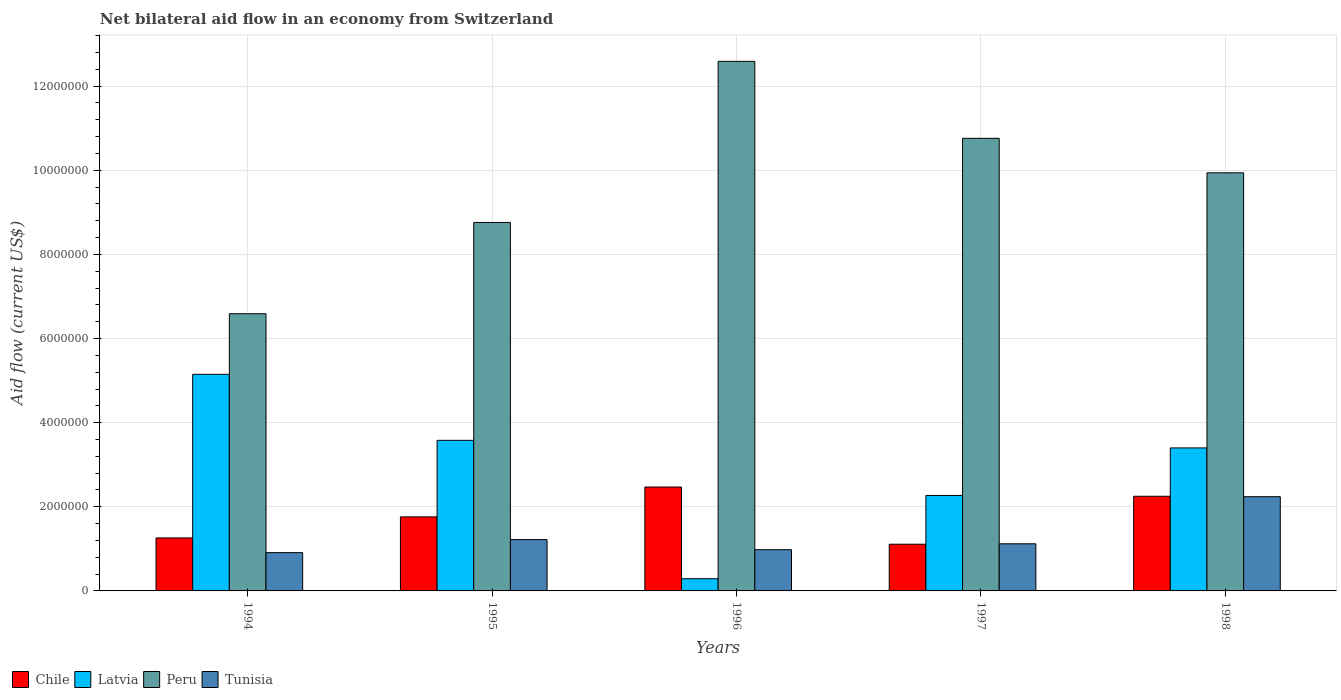How many different coloured bars are there?
Keep it short and to the point. 4. Are the number of bars per tick equal to the number of legend labels?
Your response must be concise. Yes. How many bars are there on the 1st tick from the left?
Your response must be concise. 4. What is the label of the 4th group of bars from the left?
Offer a terse response. 1997. What is the net bilateral aid flow in Peru in 1994?
Provide a short and direct response. 6.59e+06. Across all years, what is the maximum net bilateral aid flow in Chile?
Ensure brevity in your answer.  2.47e+06. Across all years, what is the minimum net bilateral aid flow in Latvia?
Your answer should be compact. 2.90e+05. In which year was the net bilateral aid flow in Chile maximum?
Offer a terse response. 1996. What is the total net bilateral aid flow in Peru in the graph?
Keep it short and to the point. 4.86e+07. What is the difference between the net bilateral aid flow in Chile in 1995 and that in 1996?
Provide a short and direct response. -7.10e+05. What is the difference between the net bilateral aid flow in Latvia in 1996 and the net bilateral aid flow in Tunisia in 1994?
Give a very brief answer. -6.20e+05. What is the average net bilateral aid flow in Peru per year?
Give a very brief answer. 9.73e+06. In the year 1994, what is the difference between the net bilateral aid flow in Latvia and net bilateral aid flow in Peru?
Offer a very short reply. -1.44e+06. In how many years, is the net bilateral aid flow in Latvia greater than 3600000 US$?
Offer a very short reply. 1. What is the ratio of the net bilateral aid flow in Tunisia in 1997 to that in 1998?
Your answer should be compact. 0.5. Is the net bilateral aid flow in Tunisia in 1995 less than that in 1997?
Your response must be concise. No. Is the difference between the net bilateral aid flow in Latvia in 1995 and 1998 greater than the difference between the net bilateral aid flow in Peru in 1995 and 1998?
Provide a short and direct response. Yes. What is the difference between the highest and the second highest net bilateral aid flow in Tunisia?
Provide a succinct answer. 1.02e+06. What is the difference between the highest and the lowest net bilateral aid flow in Chile?
Your response must be concise. 1.36e+06. Is the sum of the net bilateral aid flow in Latvia in 1995 and 1998 greater than the maximum net bilateral aid flow in Chile across all years?
Provide a succinct answer. Yes. Is it the case that in every year, the sum of the net bilateral aid flow in Chile and net bilateral aid flow in Peru is greater than the net bilateral aid flow in Latvia?
Keep it short and to the point. Yes. How many bars are there?
Provide a succinct answer. 20. Are all the bars in the graph horizontal?
Keep it short and to the point. No. How many years are there in the graph?
Your answer should be very brief. 5. What is the difference between two consecutive major ticks on the Y-axis?
Ensure brevity in your answer.  2.00e+06. Are the values on the major ticks of Y-axis written in scientific E-notation?
Offer a terse response. No. Does the graph contain any zero values?
Offer a very short reply. No. Does the graph contain grids?
Provide a short and direct response. Yes. Where does the legend appear in the graph?
Keep it short and to the point. Bottom left. What is the title of the graph?
Make the answer very short. Net bilateral aid flow in an economy from Switzerland. Does "Ukraine" appear as one of the legend labels in the graph?
Offer a very short reply. No. What is the label or title of the X-axis?
Provide a succinct answer. Years. What is the Aid flow (current US$) of Chile in 1994?
Provide a short and direct response. 1.26e+06. What is the Aid flow (current US$) in Latvia in 1994?
Provide a short and direct response. 5.15e+06. What is the Aid flow (current US$) of Peru in 1994?
Provide a succinct answer. 6.59e+06. What is the Aid flow (current US$) of Tunisia in 1994?
Ensure brevity in your answer.  9.10e+05. What is the Aid flow (current US$) of Chile in 1995?
Your answer should be compact. 1.76e+06. What is the Aid flow (current US$) in Latvia in 1995?
Offer a terse response. 3.58e+06. What is the Aid flow (current US$) in Peru in 1995?
Keep it short and to the point. 8.76e+06. What is the Aid flow (current US$) of Tunisia in 1995?
Offer a terse response. 1.22e+06. What is the Aid flow (current US$) of Chile in 1996?
Provide a short and direct response. 2.47e+06. What is the Aid flow (current US$) of Latvia in 1996?
Offer a very short reply. 2.90e+05. What is the Aid flow (current US$) in Peru in 1996?
Your answer should be compact. 1.26e+07. What is the Aid flow (current US$) of Tunisia in 1996?
Make the answer very short. 9.80e+05. What is the Aid flow (current US$) of Chile in 1997?
Keep it short and to the point. 1.11e+06. What is the Aid flow (current US$) of Latvia in 1997?
Your response must be concise. 2.27e+06. What is the Aid flow (current US$) in Peru in 1997?
Provide a short and direct response. 1.08e+07. What is the Aid flow (current US$) in Tunisia in 1997?
Provide a short and direct response. 1.12e+06. What is the Aid flow (current US$) in Chile in 1998?
Ensure brevity in your answer.  2.25e+06. What is the Aid flow (current US$) in Latvia in 1998?
Your response must be concise. 3.40e+06. What is the Aid flow (current US$) in Peru in 1998?
Keep it short and to the point. 9.94e+06. What is the Aid flow (current US$) in Tunisia in 1998?
Keep it short and to the point. 2.24e+06. Across all years, what is the maximum Aid flow (current US$) in Chile?
Provide a short and direct response. 2.47e+06. Across all years, what is the maximum Aid flow (current US$) of Latvia?
Make the answer very short. 5.15e+06. Across all years, what is the maximum Aid flow (current US$) in Peru?
Offer a terse response. 1.26e+07. Across all years, what is the maximum Aid flow (current US$) in Tunisia?
Make the answer very short. 2.24e+06. Across all years, what is the minimum Aid flow (current US$) in Chile?
Make the answer very short. 1.11e+06. Across all years, what is the minimum Aid flow (current US$) in Peru?
Give a very brief answer. 6.59e+06. Across all years, what is the minimum Aid flow (current US$) in Tunisia?
Your response must be concise. 9.10e+05. What is the total Aid flow (current US$) of Chile in the graph?
Provide a short and direct response. 8.85e+06. What is the total Aid flow (current US$) of Latvia in the graph?
Make the answer very short. 1.47e+07. What is the total Aid flow (current US$) in Peru in the graph?
Provide a succinct answer. 4.86e+07. What is the total Aid flow (current US$) of Tunisia in the graph?
Offer a very short reply. 6.47e+06. What is the difference between the Aid flow (current US$) in Chile in 1994 and that in 1995?
Your response must be concise. -5.00e+05. What is the difference between the Aid flow (current US$) in Latvia in 1994 and that in 1995?
Your answer should be very brief. 1.57e+06. What is the difference between the Aid flow (current US$) in Peru in 1994 and that in 1995?
Offer a terse response. -2.17e+06. What is the difference between the Aid flow (current US$) of Tunisia in 1994 and that in 1995?
Make the answer very short. -3.10e+05. What is the difference between the Aid flow (current US$) of Chile in 1994 and that in 1996?
Ensure brevity in your answer.  -1.21e+06. What is the difference between the Aid flow (current US$) in Latvia in 1994 and that in 1996?
Keep it short and to the point. 4.86e+06. What is the difference between the Aid flow (current US$) in Peru in 1994 and that in 1996?
Offer a very short reply. -6.00e+06. What is the difference between the Aid flow (current US$) in Latvia in 1994 and that in 1997?
Offer a very short reply. 2.88e+06. What is the difference between the Aid flow (current US$) in Peru in 1994 and that in 1997?
Provide a succinct answer. -4.17e+06. What is the difference between the Aid flow (current US$) in Chile in 1994 and that in 1998?
Provide a short and direct response. -9.90e+05. What is the difference between the Aid flow (current US$) of Latvia in 1994 and that in 1998?
Your answer should be compact. 1.75e+06. What is the difference between the Aid flow (current US$) in Peru in 1994 and that in 1998?
Keep it short and to the point. -3.35e+06. What is the difference between the Aid flow (current US$) of Tunisia in 1994 and that in 1998?
Ensure brevity in your answer.  -1.33e+06. What is the difference between the Aid flow (current US$) of Chile in 1995 and that in 1996?
Your answer should be very brief. -7.10e+05. What is the difference between the Aid flow (current US$) of Latvia in 1995 and that in 1996?
Ensure brevity in your answer.  3.29e+06. What is the difference between the Aid flow (current US$) in Peru in 1995 and that in 1996?
Provide a short and direct response. -3.83e+06. What is the difference between the Aid flow (current US$) in Chile in 1995 and that in 1997?
Offer a terse response. 6.50e+05. What is the difference between the Aid flow (current US$) of Latvia in 1995 and that in 1997?
Give a very brief answer. 1.31e+06. What is the difference between the Aid flow (current US$) of Chile in 1995 and that in 1998?
Make the answer very short. -4.90e+05. What is the difference between the Aid flow (current US$) of Peru in 1995 and that in 1998?
Provide a succinct answer. -1.18e+06. What is the difference between the Aid flow (current US$) of Tunisia in 1995 and that in 1998?
Ensure brevity in your answer.  -1.02e+06. What is the difference between the Aid flow (current US$) in Chile in 1996 and that in 1997?
Your answer should be very brief. 1.36e+06. What is the difference between the Aid flow (current US$) of Latvia in 1996 and that in 1997?
Make the answer very short. -1.98e+06. What is the difference between the Aid flow (current US$) in Peru in 1996 and that in 1997?
Your answer should be compact. 1.83e+06. What is the difference between the Aid flow (current US$) of Tunisia in 1996 and that in 1997?
Your response must be concise. -1.40e+05. What is the difference between the Aid flow (current US$) in Latvia in 1996 and that in 1998?
Make the answer very short. -3.11e+06. What is the difference between the Aid flow (current US$) in Peru in 1996 and that in 1998?
Make the answer very short. 2.65e+06. What is the difference between the Aid flow (current US$) in Tunisia in 1996 and that in 1998?
Your response must be concise. -1.26e+06. What is the difference between the Aid flow (current US$) in Chile in 1997 and that in 1998?
Make the answer very short. -1.14e+06. What is the difference between the Aid flow (current US$) in Latvia in 1997 and that in 1998?
Your answer should be very brief. -1.13e+06. What is the difference between the Aid flow (current US$) of Peru in 1997 and that in 1998?
Offer a very short reply. 8.20e+05. What is the difference between the Aid flow (current US$) of Tunisia in 1997 and that in 1998?
Offer a very short reply. -1.12e+06. What is the difference between the Aid flow (current US$) in Chile in 1994 and the Aid flow (current US$) in Latvia in 1995?
Keep it short and to the point. -2.32e+06. What is the difference between the Aid flow (current US$) in Chile in 1994 and the Aid flow (current US$) in Peru in 1995?
Provide a succinct answer. -7.50e+06. What is the difference between the Aid flow (current US$) in Chile in 1994 and the Aid flow (current US$) in Tunisia in 1995?
Offer a very short reply. 4.00e+04. What is the difference between the Aid flow (current US$) in Latvia in 1994 and the Aid flow (current US$) in Peru in 1995?
Keep it short and to the point. -3.61e+06. What is the difference between the Aid flow (current US$) of Latvia in 1994 and the Aid flow (current US$) of Tunisia in 1995?
Your answer should be compact. 3.93e+06. What is the difference between the Aid flow (current US$) in Peru in 1994 and the Aid flow (current US$) in Tunisia in 1995?
Your response must be concise. 5.37e+06. What is the difference between the Aid flow (current US$) in Chile in 1994 and the Aid flow (current US$) in Latvia in 1996?
Provide a short and direct response. 9.70e+05. What is the difference between the Aid flow (current US$) of Chile in 1994 and the Aid flow (current US$) of Peru in 1996?
Ensure brevity in your answer.  -1.13e+07. What is the difference between the Aid flow (current US$) in Chile in 1994 and the Aid flow (current US$) in Tunisia in 1996?
Provide a short and direct response. 2.80e+05. What is the difference between the Aid flow (current US$) of Latvia in 1994 and the Aid flow (current US$) of Peru in 1996?
Offer a terse response. -7.44e+06. What is the difference between the Aid flow (current US$) of Latvia in 1994 and the Aid flow (current US$) of Tunisia in 1996?
Offer a very short reply. 4.17e+06. What is the difference between the Aid flow (current US$) of Peru in 1994 and the Aid flow (current US$) of Tunisia in 1996?
Your response must be concise. 5.61e+06. What is the difference between the Aid flow (current US$) in Chile in 1994 and the Aid flow (current US$) in Latvia in 1997?
Provide a succinct answer. -1.01e+06. What is the difference between the Aid flow (current US$) in Chile in 1994 and the Aid flow (current US$) in Peru in 1997?
Keep it short and to the point. -9.50e+06. What is the difference between the Aid flow (current US$) in Chile in 1994 and the Aid flow (current US$) in Tunisia in 1997?
Offer a very short reply. 1.40e+05. What is the difference between the Aid flow (current US$) of Latvia in 1994 and the Aid flow (current US$) of Peru in 1997?
Provide a succinct answer. -5.61e+06. What is the difference between the Aid flow (current US$) of Latvia in 1994 and the Aid flow (current US$) of Tunisia in 1997?
Make the answer very short. 4.03e+06. What is the difference between the Aid flow (current US$) of Peru in 1994 and the Aid flow (current US$) of Tunisia in 1997?
Make the answer very short. 5.47e+06. What is the difference between the Aid flow (current US$) in Chile in 1994 and the Aid flow (current US$) in Latvia in 1998?
Keep it short and to the point. -2.14e+06. What is the difference between the Aid flow (current US$) of Chile in 1994 and the Aid flow (current US$) of Peru in 1998?
Provide a short and direct response. -8.68e+06. What is the difference between the Aid flow (current US$) in Chile in 1994 and the Aid flow (current US$) in Tunisia in 1998?
Your response must be concise. -9.80e+05. What is the difference between the Aid flow (current US$) of Latvia in 1994 and the Aid flow (current US$) of Peru in 1998?
Ensure brevity in your answer.  -4.79e+06. What is the difference between the Aid flow (current US$) in Latvia in 1994 and the Aid flow (current US$) in Tunisia in 1998?
Give a very brief answer. 2.91e+06. What is the difference between the Aid flow (current US$) of Peru in 1994 and the Aid flow (current US$) of Tunisia in 1998?
Ensure brevity in your answer.  4.35e+06. What is the difference between the Aid flow (current US$) of Chile in 1995 and the Aid flow (current US$) of Latvia in 1996?
Offer a terse response. 1.47e+06. What is the difference between the Aid flow (current US$) of Chile in 1995 and the Aid flow (current US$) of Peru in 1996?
Ensure brevity in your answer.  -1.08e+07. What is the difference between the Aid flow (current US$) in Chile in 1995 and the Aid flow (current US$) in Tunisia in 1996?
Your answer should be very brief. 7.80e+05. What is the difference between the Aid flow (current US$) of Latvia in 1995 and the Aid flow (current US$) of Peru in 1996?
Your answer should be compact. -9.01e+06. What is the difference between the Aid flow (current US$) of Latvia in 1995 and the Aid flow (current US$) of Tunisia in 1996?
Keep it short and to the point. 2.60e+06. What is the difference between the Aid flow (current US$) in Peru in 1995 and the Aid flow (current US$) in Tunisia in 1996?
Provide a short and direct response. 7.78e+06. What is the difference between the Aid flow (current US$) of Chile in 1995 and the Aid flow (current US$) of Latvia in 1997?
Provide a succinct answer. -5.10e+05. What is the difference between the Aid flow (current US$) in Chile in 1995 and the Aid flow (current US$) in Peru in 1997?
Give a very brief answer. -9.00e+06. What is the difference between the Aid flow (current US$) in Chile in 1995 and the Aid flow (current US$) in Tunisia in 1997?
Keep it short and to the point. 6.40e+05. What is the difference between the Aid flow (current US$) in Latvia in 1995 and the Aid flow (current US$) in Peru in 1997?
Provide a succinct answer. -7.18e+06. What is the difference between the Aid flow (current US$) of Latvia in 1995 and the Aid flow (current US$) of Tunisia in 1997?
Provide a short and direct response. 2.46e+06. What is the difference between the Aid flow (current US$) of Peru in 1995 and the Aid flow (current US$) of Tunisia in 1997?
Make the answer very short. 7.64e+06. What is the difference between the Aid flow (current US$) of Chile in 1995 and the Aid flow (current US$) of Latvia in 1998?
Offer a terse response. -1.64e+06. What is the difference between the Aid flow (current US$) of Chile in 1995 and the Aid flow (current US$) of Peru in 1998?
Provide a succinct answer. -8.18e+06. What is the difference between the Aid flow (current US$) of Chile in 1995 and the Aid flow (current US$) of Tunisia in 1998?
Give a very brief answer. -4.80e+05. What is the difference between the Aid flow (current US$) in Latvia in 1995 and the Aid flow (current US$) in Peru in 1998?
Provide a short and direct response. -6.36e+06. What is the difference between the Aid flow (current US$) in Latvia in 1995 and the Aid flow (current US$) in Tunisia in 1998?
Keep it short and to the point. 1.34e+06. What is the difference between the Aid flow (current US$) of Peru in 1995 and the Aid flow (current US$) of Tunisia in 1998?
Ensure brevity in your answer.  6.52e+06. What is the difference between the Aid flow (current US$) in Chile in 1996 and the Aid flow (current US$) in Peru in 1997?
Keep it short and to the point. -8.29e+06. What is the difference between the Aid flow (current US$) of Chile in 1996 and the Aid flow (current US$) of Tunisia in 1997?
Provide a succinct answer. 1.35e+06. What is the difference between the Aid flow (current US$) in Latvia in 1996 and the Aid flow (current US$) in Peru in 1997?
Keep it short and to the point. -1.05e+07. What is the difference between the Aid flow (current US$) in Latvia in 1996 and the Aid flow (current US$) in Tunisia in 1997?
Offer a terse response. -8.30e+05. What is the difference between the Aid flow (current US$) of Peru in 1996 and the Aid flow (current US$) of Tunisia in 1997?
Give a very brief answer. 1.15e+07. What is the difference between the Aid flow (current US$) in Chile in 1996 and the Aid flow (current US$) in Latvia in 1998?
Make the answer very short. -9.30e+05. What is the difference between the Aid flow (current US$) of Chile in 1996 and the Aid flow (current US$) of Peru in 1998?
Keep it short and to the point. -7.47e+06. What is the difference between the Aid flow (current US$) of Chile in 1996 and the Aid flow (current US$) of Tunisia in 1998?
Give a very brief answer. 2.30e+05. What is the difference between the Aid flow (current US$) in Latvia in 1996 and the Aid flow (current US$) in Peru in 1998?
Provide a short and direct response. -9.65e+06. What is the difference between the Aid flow (current US$) in Latvia in 1996 and the Aid flow (current US$) in Tunisia in 1998?
Offer a very short reply. -1.95e+06. What is the difference between the Aid flow (current US$) in Peru in 1996 and the Aid flow (current US$) in Tunisia in 1998?
Give a very brief answer. 1.04e+07. What is the difference between the Aid flow (current US$) of Chile in 1997 and the Aid flow (current US$) of Latvia in 1998?
Make the answer very short. -2.29e+06. What is the difference between the Aid flow (current US$) in Chile in 1997 and the Aid flow (current US$) in Peru in 1998?
Provide a short and direct response. -8.83e+06. What is the difference between the Aid flow (current US$) of Chile in 1997 and the Aid flow (current US$) of Tunisia in 1998?
Your response must be concise. -1.13e+06. What is the difference between the Aid flow (current US$) of Latvia in 1997 and the Aid flow (current US$) of Peru in 1998?
Provide a short and direct response. -7.67e+06. What is the difference between the Aid flow (current US$) of Peru in 1997 and the Aid flow (current US$) of Tunisia in 1998?
Offer a very short reply. 8.52e+06. What is the average Aid flow (current US$) in Chile per year?
Offer a terse response. 1.77e+06. What is the average Aid flow (current US$) in Latvia per year?
Provide a succinct answer. 2.94e+06. What is the average Aid flow (current US$) of Peru per year?
Provide a short and direct response. 9.73e+06. What is the average Aid flow (current US$) in Tunisia per year?
Provide a succinct answer. 1.29e+06. In the year 1994, what is the difference between the Aid flow (current US$) in Chile and Aid flow (current US$) in Latvia?
Offer a terse response. -3.89e+06. In the year 1994, what is the difference between the Aid flow (current US$) in Chile and Aid flow (current US$) in Peru?
Your answer should be compact. -5.33e+06. In the year 1994, what is the difference between the Aid flow (current US$) of Latvia and Aid flow (current US$) of Peru?
Your answer should be very brief. -1.44e+06. In the year 1994, what is the difference between the Aid flow (current US$) of Latvia and Aid flow (current US$) of Tunisia?
Make the answer very short. 4.24e+06. In the year 1994, what is the difference between the Aid flow (current US$) in Peru and Aid flow (current US$) in Tunisia?
Give a very brief answer. 5.68e+06. In the year 1995, what is the difference between the Aid flow (current US$) in Chile and Aid flow (current US$) in Latvia?
Your response must be concise. -1.82e+06. In the year 1995, what is the difference between the Aid flow (current US$) of Chile and Aid flow (current US$) of Peru?
Keep it short and to the point. -7.00e+06. In the year 1995, what is the difference between the Aid flow (current US$) in Chile and Aid flow (current US$) in Tunisia?
Make the answer very short. 5.40e+05. In the year 1995, what is the difference between the Aid flow (current US$) in Latvia and Aid flow (current US$) in Peru?
Ensure brevity in your answer.  -5.18e+06. In the year 1995, what is the difference between the Aid flow (current US$) in Latvia and Aid flow (current US$) in Tunisia?
Your answer should be compact. 2.36e+06. In the year 1995, what is the difference between the Aid flow (current US$) in Peru and Aid flow (current US$) in Tunisia?
Your answer should be very brief. 7.54e+06. In the year 1996, what is the difference between the Aid flow (current US$) in Chile and Aid flow (current US$) in Latvia?
Your answer should be compact. 2.18e+06. In the year 1996, what is the difference between the Aid flow (current US$) of Chile and Aid flow (current US$) of Peru?
Give a very brief answer. -1.01e+07. In the year 1996, what is the difference between the Aid flow (current US$) in Chile and Aid flow (current US$) in Tunisia?
Keep it short and to the point. 1.49e+06. In the year 1996, what is the difference between the Aid flow (current US$) in Latvia and Aid flow (current US$) in Peru?
Offer a very short reply. -1.23e+07. In the year 1996, what is the difference between the Aid flow (current US$) in Latvia and Aid flow (current US$) in Tunisia?
Provide a succinct answer. -6.90e+05. In the year 1996, what is the difference between the Aid flow (current US$) of Peru and Aid flow (current US$) of Tunisia?
Your answer should be very brief. 1.16e+07. In the year 1997, what is the difference between the Aid flow (current US$) in Chile and Aid flow (current US$) in Latvia?
Offer a terse response. -1.16e+06. In the year 1997, what is the difference between the Aid flow (current US$) in Chile and Aid flow (current US$) in Peru?
Give a very brief answer. -9.65e+06. In the year 1997, what is the difference between the Aid flow (current US$) of Latvia and Aid flow (current US$) of Peru?
Keep it short and to the point. -8.49e+06. In the year 1997, what is the difference between the Aid flow (current US$) in Latvia and Aid flow (current US$) in Tunisia?
Make the answer very short. 1.15e+06. In the year 1997, what is the difference between the Aid flow (current US$) of Peru and Aid flow (current US$) of Tunisia?
Provide a succinct answer. 9.64e+06. In the year 1998, what is the difference between the Aid flow (current US$) in Chile and Aid flow (current US$) in Latvia?
Offer a terse response. -1.15e+06. In the year 1998, what is the difference between the Aid flow (current US$) in Chile and Aid flow (current US$) in Peru?
Offer a terse response. -7.69e+06. In the year 1998, what is the difference between the Aid flow (current US$) of Chile and Aid flow (current US$) of Tunisia?
Ensure brevity in your answer.  10000. In the year 1998, what is the difference between the Aid flow (current US$) in Latvia and Aid flow (current US$) in Peru?
Make the answer very short. -6.54e+06. In the year 1998, what is the difference between the Aid flow (current US$) of Latvia and Aid flow (current US$) of Tunisia?
Keep it short and to the point. 1.16e+06. In the year 1998, what is the difference between the Aid flow (current US$) in Peru and Aid flow (current US$) in Tunisia?
Offer a very short reply. 7.70e+06. What is the ratio of the Aid flow (current US$) in Chile in 1994 to that in 1995?
Offer a very short reply. 0.72. What is the ratio of the Aid flow (current US$) of Latvia in 1994 to that in 1995?
Give a very brief answer. 1.44. What is the ratio of the Aid flow (current US$) of Peru in 1994 to that in 1995?
Make the answer very short. 0.75. What is the ratio of the Aid flow (current US$) in Tunisia in 1994 to that in 1995?
Provide a succinct answer. 0.75. What is the ratio of the Aid flow (current US$) in Chile in 1994 to that in 1996?
Offer a very short reply. 0.51. What is the ratio of the Aid flow (current US$) in Latvia in 1994 to that in 1996?
Provide a short and direct response. 17.76. What is the ratio of the Aid flow (current US$) in Peru in 1994 to that in 1996?
Ensure brevity in your answer.  0.52. What is the ratio of the Aid flow (current US$) of Tunisia in 1994 to that in 1996?
Offer a very short reply. 0.93. What is the ratio of the Aid flow (current US$) in Chile in 1994 to that in 1997?
Give a very brief answer. 1.14. What is the ratio of the Aid flow (current US$) in Latvia in 1994 to that in 1997?
Ensure brevity in your answer.  2.27. What is the ratio of the Aid flow (current US$) of Peru in 1994 to that in 1997?
Offer a very short reply. 0.61. What is the ratio of the Aid flow (current US$) of Tunisia in 1994 to that in 1997?
Provide a succinct answer. 0.81. What is the ratio of the Aid flow (current US$) in Chile in 1994 to that in 1998?
Make the answer very short. 0.56. What is the ratio of the Aid flow (current US$) of Latvia in 1994 to that in 1998?
Offer a terse response. 1.51. What is the ratio of the Aid flow (current US$) of Peru in 1994 to that in 1998?
Your answer should be very brief. 0.66. What is the ratio of the Aid flow (current US$) of Tunisia in 1994 to that in 1998?
Give a very brief answer. 0.41. What is the ratio of the Aid flow (current US$) in Chile in 1995 to that in 1996?
Your response must be concise. 0.71. What is the ratio of the Aid flow (current US$) in Latvia in 1995 to that in 1996?
Keep it short and to the point. 12.34. What is the ratio of the Aid flow (current US$) in Peru in 1995 to that in 1996?
Ensure brevity in your answer.  0.7. What is the ratio of the Aid flow (current US$) in Tunisia in 1995 to that in 1996?
Provide a short and direct response. 1.24. What is the ratio of the Aid flow (current US$) of Chile in 1995 to that in 1997?
Provide a succinct answer. 1.59. What is the ratio of the Aid flow (current US$) in Latvia in 1995 to that in 1997?
Your answer should be very brief. 1.58. What is the ratio of the Aid flow (current US$) in Peru in 1995 to that in 1997?
Your answer should be very brief. 0.81. What is the ratio of the Aid flow (current US$) of Tunisia in 1995 to that in 1997?
Provide a short and direct response. 1.09. What is the ratio of the Aid flow (current US$) of Chile in 1995 to that in 1998?
Provide a short and direct response. 0.78. What is the ratio of the Aid flow (current US$) in Latvia in 1995 to that in 1998?
Your answer should be very brief. 1.05. What is the ratio of the Aid flow (current US$) in Peru in 1995 to that in 1998?
Offer a terse response. 0.88. What is the ratio of the Aid flow (current US$) of Tunisia in 1995 to that in 1998?
Offer a terse response. 0.54. What is the ratio of the Aid flow (current US$) in Chile in 1996 to that in 1997?
Offer a very short reply. 2.23. What is the ratio of the Aid flow (current US$) in Latvia in 1996 to that in 1997?
Give a very brief answer. 0.13. What is the ratio of the Aid flow (current US$) of Peru in 1996 to that in 1997?
Provide a succinct answer. 1.17. What is the ratio of the Aid flow (current US$) in Tunisia in 1996 to that in 1997?
Your answer should be very brief. 0.88. What is the ratio of the Aid flow (current US$) in Chile in 1996 to that in 1998?
Keep it short and to the point. 1.1. What is the ratio of the Aid flow (current US$) in Latvia in 1996 to that in 1998?
Your response must be concise. 0.09. What is the ratio of the Aid flow (current US$) of Peru in 1996 to that in 1998?
Your response must be concise. 1.27. What is the ratio of the Aid flow (current US$) of Tunisia in 1996 to that in 1998?
Your answer should be compact. 0.44. What is the ratio of the Aid flow (current US$) of Chile in 1997 to that in 1998?
Your response must be concise. 0.49. What is the ratio of the Aid flow (current US$) in Latvia in 1997 to that in 1998?
Provide a succinct answer. 0.67. What is the ratio of the Aid flow (current US$) in Peru in 1997 to that in 1998?
Make the answer very short. 1.08. What is the ratio of the Aid flow (current US$) in Tunisia in 1997 to that in 1998?
Give a very brief answer. 0.5. What is the difference between the highest and the second highest Aid flow (current US$) of Chile?
Provide a succinct answer. 2.20e+05. What is the difference between the highest and the second highest Aid flow (current US$) of Latvia?
Make the answer very short. 1.57e+06. What is the difference between the highest and the second highest Aid flow (current US$) of Peru?
Make the answer very short. 1.83e+06. What is the difference between the highest and the second highest Aid flow (current US$) of Tunisia?
Your answer should be very brief. 1.02e+06. What is the difference between the highest and the lowest Aid flow (current US$) of Chile?
Make the answer very short. 1.36e+06. What is the difference between the highest and the lowest Aid flow (current US$) of Latvia?
Provide a short and direct response. 4.86e+06. What is the difference between the highest and the lowest Aid flow (current US$) of Peru?
Offer a terse response. 6.00e+06. What is the difference between the highest and the lowest Aid flow (current US$) of Tunisia?
Ensure brevity in your answer.  1.33e+06. 